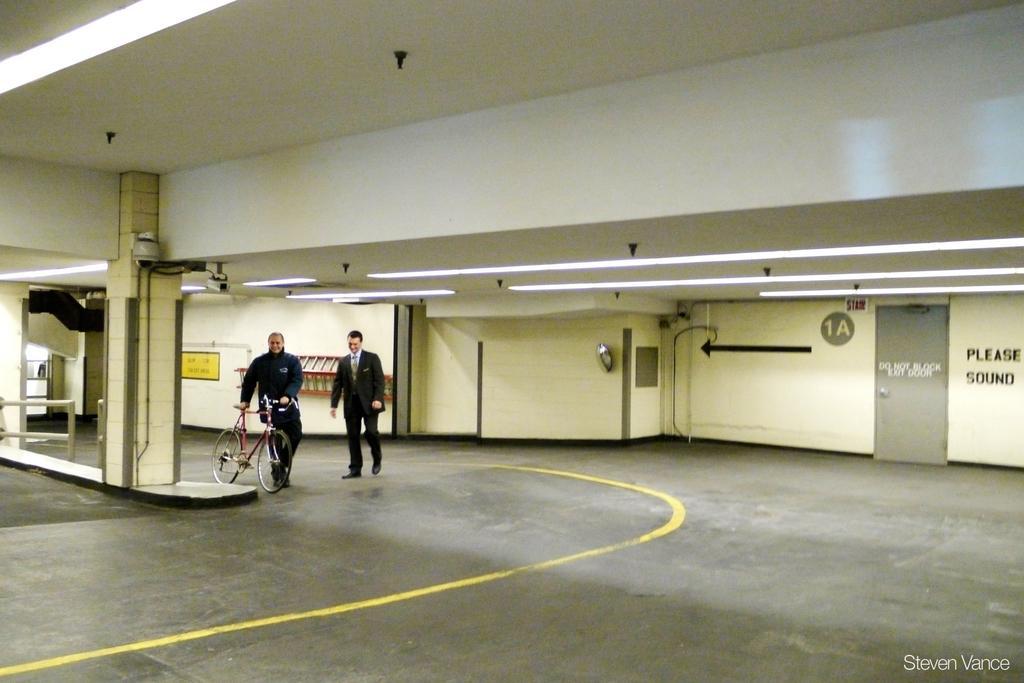Can you describe this image briefly? In this image we can see two persons are walking, one of them is holding a bicycle, there are text and symbols on the wall, there are lights, a pillar, railing, also we can see the roof. 